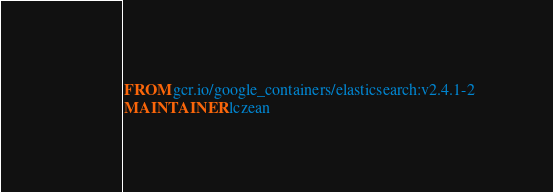Convert code to text. <code><loc_0><loc_0><loc_500><loc_500><_Dockerfile_>FROM gcr.io/google_containers/elasticsearch:v2.4.1-2
MAINTAINER lczean
</code> 